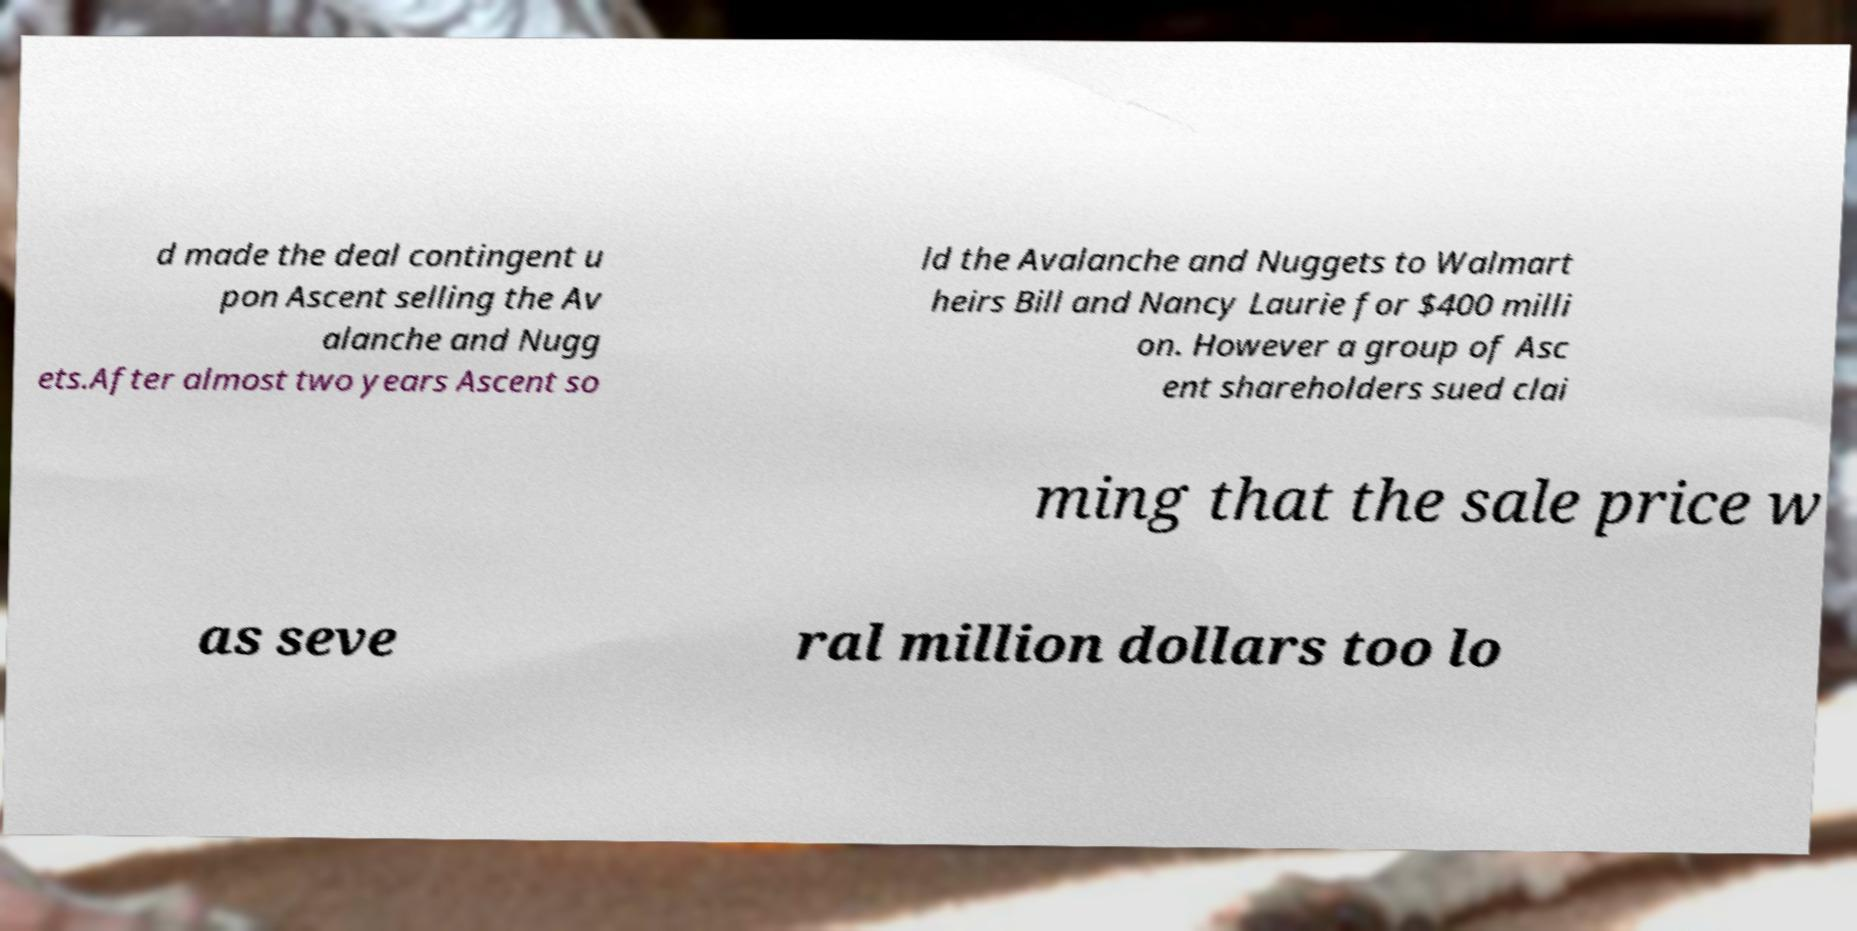Could you assist in decoding the text presented in this image and type it out clearly? d made the deal contingent u pon Ascent selling the Av alanche and Nugg ets.After almost two years Ascent so ld the Avalanche and Nuggets to Walmart heirs Bill and Nancy Laurie for $400 milli on. However a group of Asc ent shareholders sued clai ming that the sale price w as seve ral million dollars too lo 